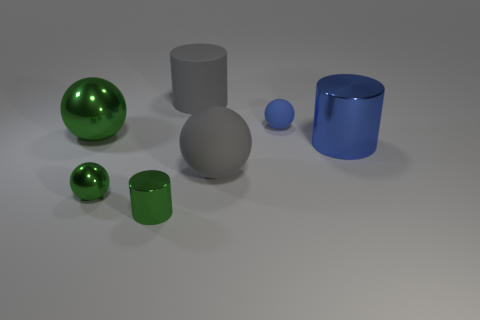The small sphere to the left of the big gray object behind the big matte object that is in front of the big gray cylinder is made of what material?
Make the answer very short. Metal. There is a small thing that is the same color as the small cylinder; what material is it?
Your answer should be compact. Metal. What number of things are small rubber things or small purple metal things?
Keep it short and to the point. 1. Do the big gray object that is in front of the blue metal thing and the large blue object have the same material?
Your response must be concise. No. What number of objects are either small objects that are on the left side of the green metallic cylinder or large cyan shiny blocks?
Make the answer very short. 1. What color is the small ball that is the same material as the small cylinder?
Ensure brevity in your answer.  Green. Is there a gray matte object of the same size as the rubber cylinder?
Your response must be concise. Yes. There is a big metal object to the left of the large gray matte cylinder; is it the same color as the small metal cylinder?
Make the answer very short. Yes. What is the color of the object that is both right of the gray sphere and behind the blue shiny cylinder?
Offer a terse response. Blue. What shape is the green shiny thing that is the same size as the matte cylinder?
Keep it short and to the point. Sphere. 